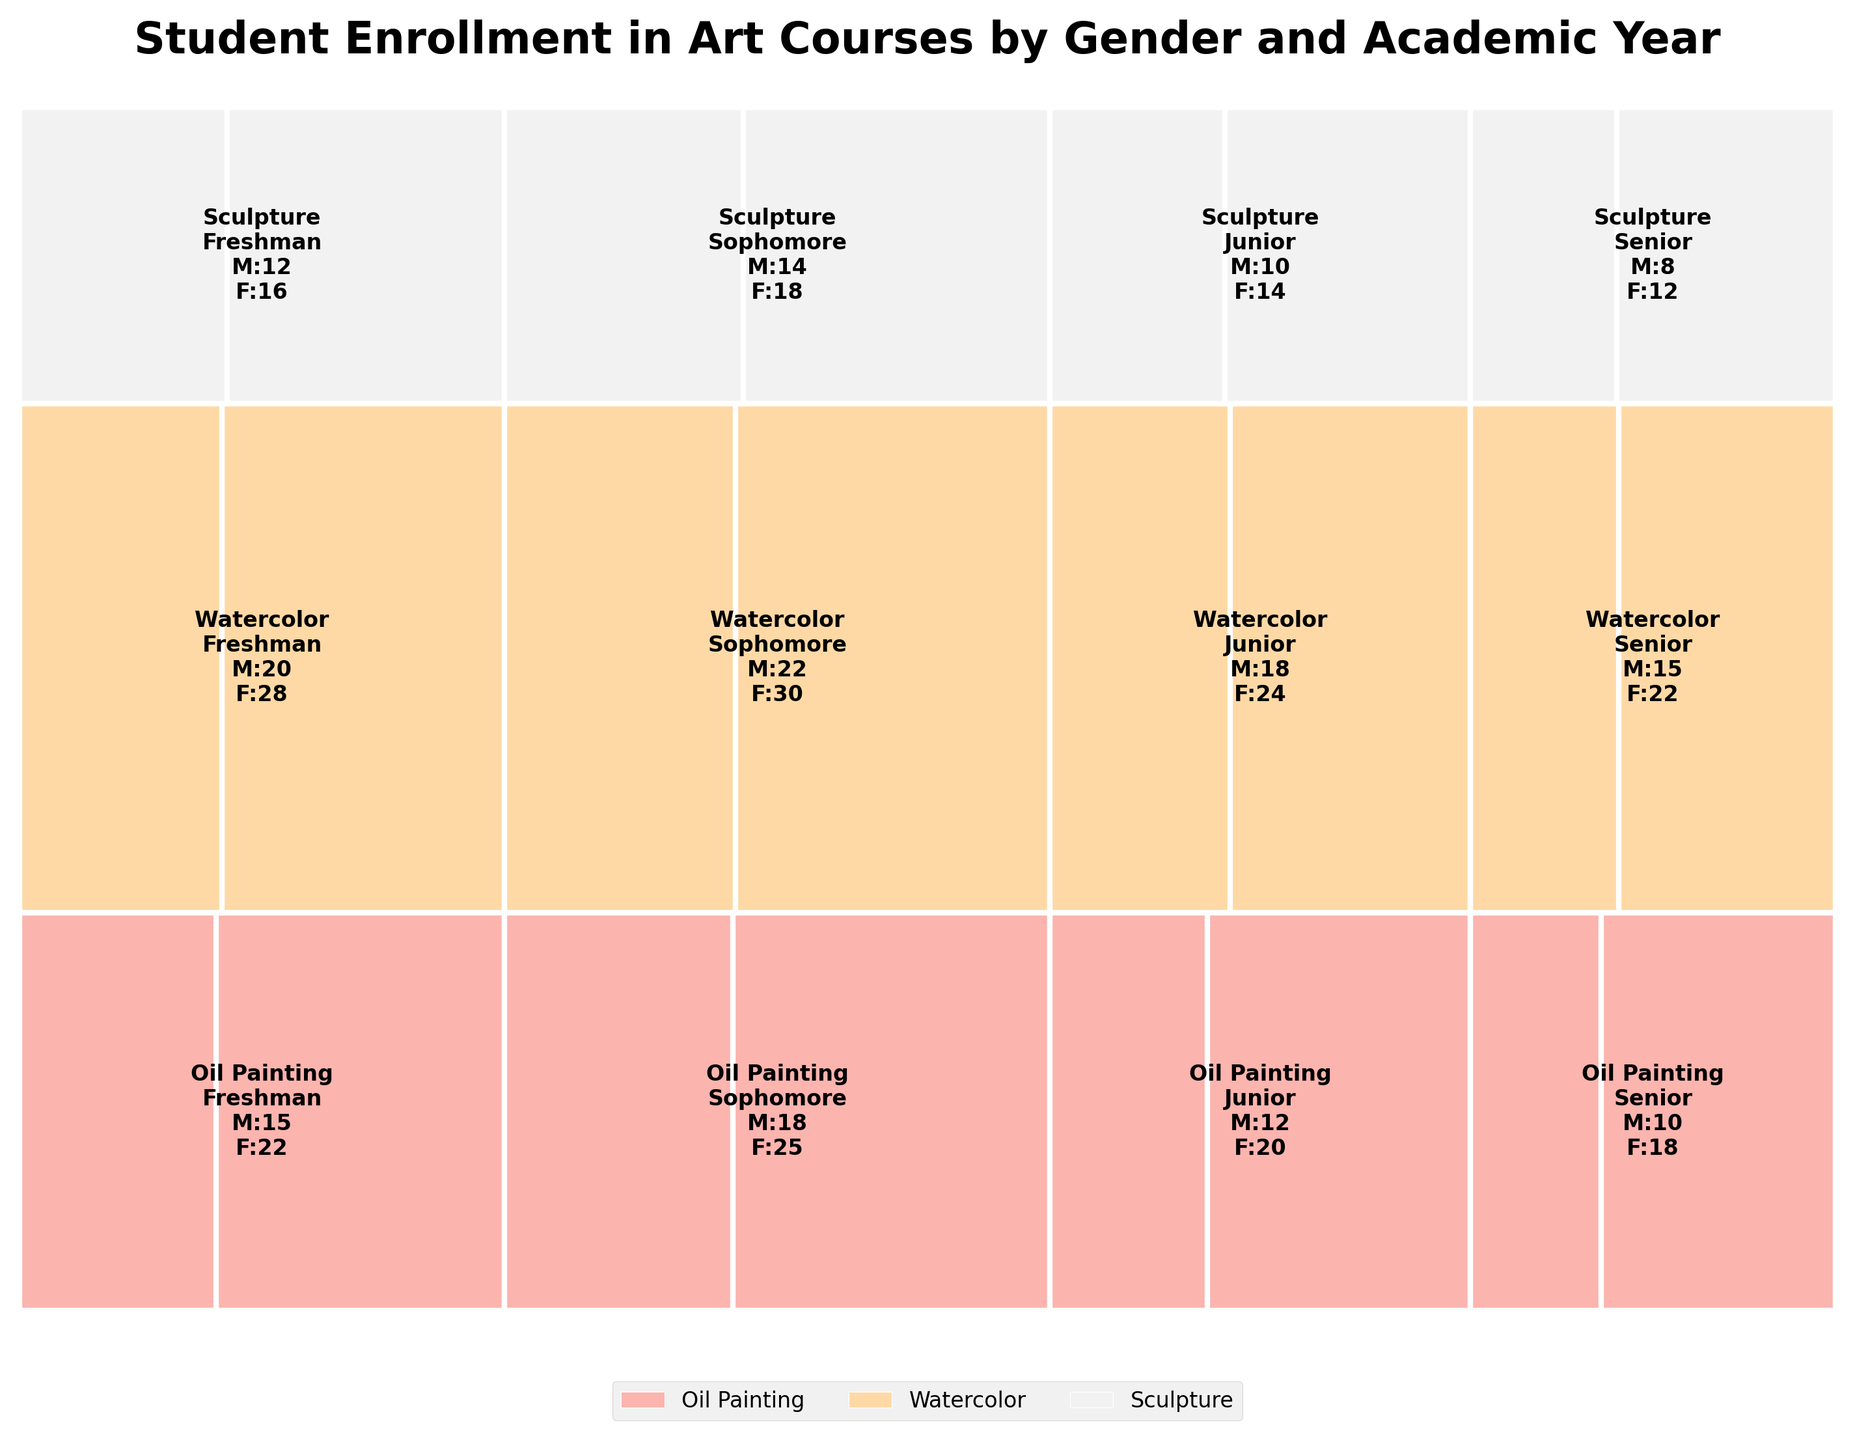What is the title of the mosaic plot? The title is displayed clearly at the top of the plot.
Answer: "Student Enrollment in Art Courses by Gender and Academic Year" Which course has the highest total enrollment? By looking at the largest overall height of the sections for each course, determine which is the tallest.
Answer: Watercolor Are there more Male or Female students enrolled in Junior Watercolor courses? Find the section of the plot corresponding to Junior Watercolor, then look for the split between Male and Female students. The Female section is visibly larger.
Answer: Female Which academic year shows the most total enrollment for Sculpture? Analyze the width of the rectangles for Sculpture across different years. The widest section corresponds to the year with the most enrollment.
Answer: Freshman How does the enrollment for Sophomore Oil Painting compare between genders? Examine the Sophomore Oil Painting section. Compare the sizes of the male and female segments. Females have a larger section.
Answer: Females have higher enrollment What is the proportion of Male students in Senior courses relative to the entire plot? Observe all the Senior sections, noting the overall height and comparing the Male portions to the whole plot. Summing each Male section as a fraction of the total plot height gives the proportion.
Answer: 5% Is there a course where Seniors are the least enrolled, and what is it? Compare the total heights of the Senior enrollment sections for each course. The smallest height represents the least enrolled course.
Answer: Sculpture What's the difference in total enrollment between Freshman and Senior students in Oil Painting? Calculate the total enrollments by adding up Male and Female numbers for each year and find the difference between Freshman and Senior.
Answer: 9 (35 - 26) Are Female students more consistently enrolled across different courses than Male students? Compare the consistency of Female sections' heights across courses to the variations in Male sections. Female sections appear more uniform in size across courses.
Answer: Yes, more consistent Which course shows a more balanced gender enrollment throughout all academic years? Look for the course with sections that have the smallest splits between genders across all years.
Answer: Watercolor 